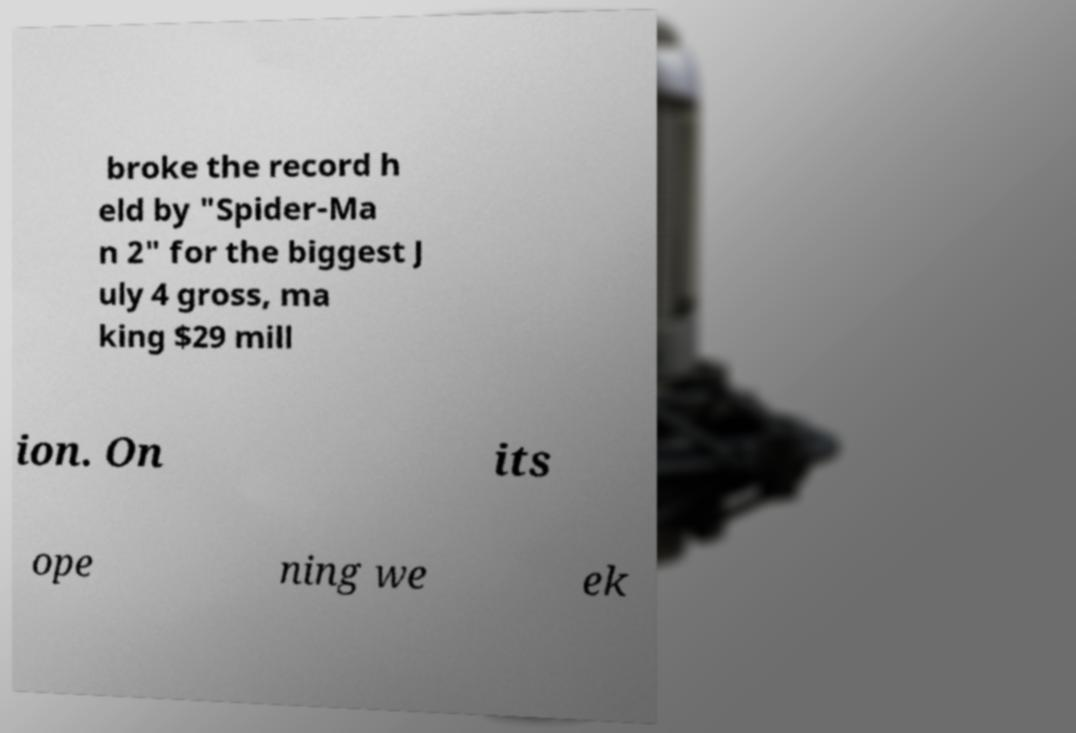Could you extract and type out the text from this image? broke the record h eld by "Spider-Ma n 2" for the biggest J uly 4 gross, ma king $29 mill ion. On its ope ning we ek 